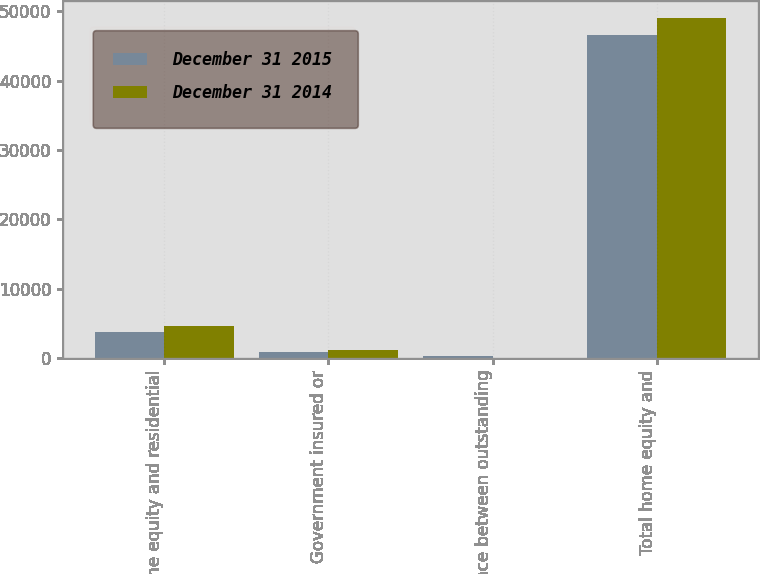<chart> <loc_0><loc_0><loc_500><loc_500><stacked_bar_chart><ecel><fcel>Home equity and residential<fcel>Government insured or<fcel>Difference between outstanding<fcel>Total home equity and<nl><fcel>December 31 2015<fcel>3684<fcel>923<fcel>331<fcel>46544<nl><fcel>December 31 2014<fcel>4541<fcel>1188<fcel>7<fcel>49084<nl></chart> 